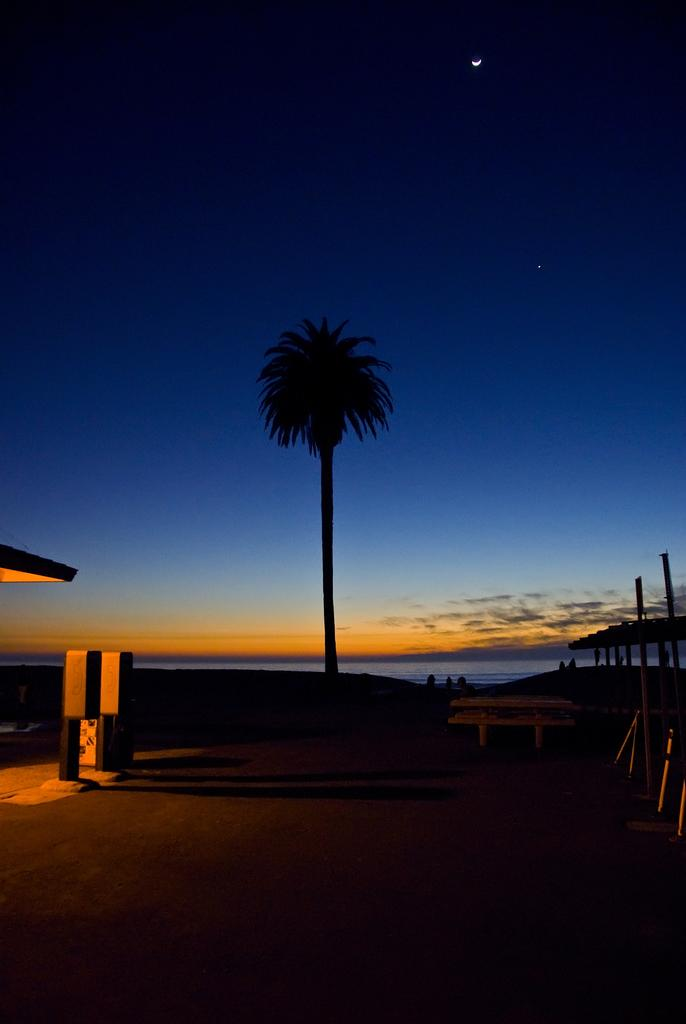What is the main subject in the middle of the image? There is a tree in the middle of the image. What else can be seen in the image besides the tree? Water and the sky are visible in the image. What can be inferred about the time of day based on the image? The time of day appears to be evening. What type of reward is being given to the wrist in the image? There is no wrist or reward present in the image. Are there any fairies visible in the image? There are no fairies present in the image. 